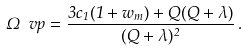Convert formula to latex. <formula><loc_0><loc_0><loc_500><loc_500>\Omega _ { \ } v p = \frac { 3 c _ { 1 } ( 1 + w _ { m } ) + Q ( Q + \lambda ) } { ( Q + \lambda ) ^ { 2 } } \, .</formula> 